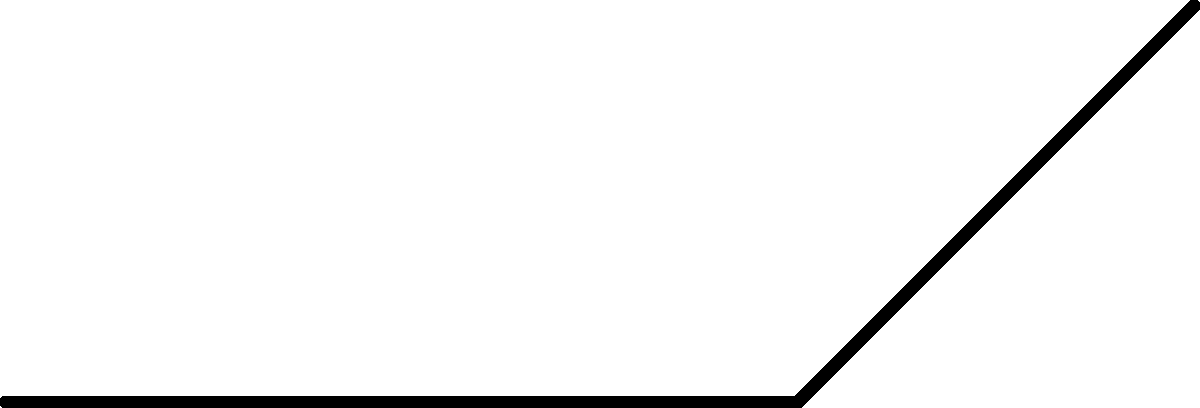In the simplified arm model shown above, the biceps muscle exerts a force $F_m = 200$ N at an angle of $\theta = 30°$ to the horizontal. Calculate the magnitude of the vertical component ($F_y$) of the muscle force acting on the ulna. To solve this problem, we'll follow these steps:

1) First, recall the formula for calculating the vertical component of a force vector:

   $F_y = F_m \sin(\theta)$

   Where $F_m$ is the magnitude of the muscle force and $\theta$ is the angle between the force vector and the horizontal.

2) We're given:
   $F_m = 200$ N
   $\theta = 30°$

3) Now, let's substitute these values into our equation:

   $F_y = 200 \sin(30°)$

4) We know that $\sin(30°) = 0.5$, so:

   $F_y = 200 \cdot 0.5 = 100$ N

Therefore, the magnitude of the vertical component of the muscle force is 100 N.
Answer: 100 N 